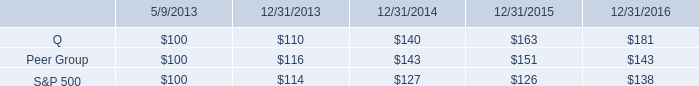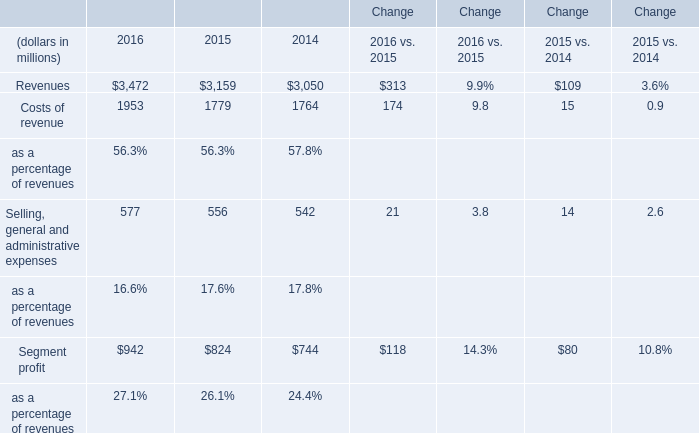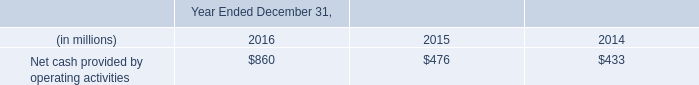What was the average of the Selling, general and administrative expenses in the years where Revenues is positive? (in million) 
Computations: (((577 + 556) + 542) / 3)
Answer: 558.33333. 